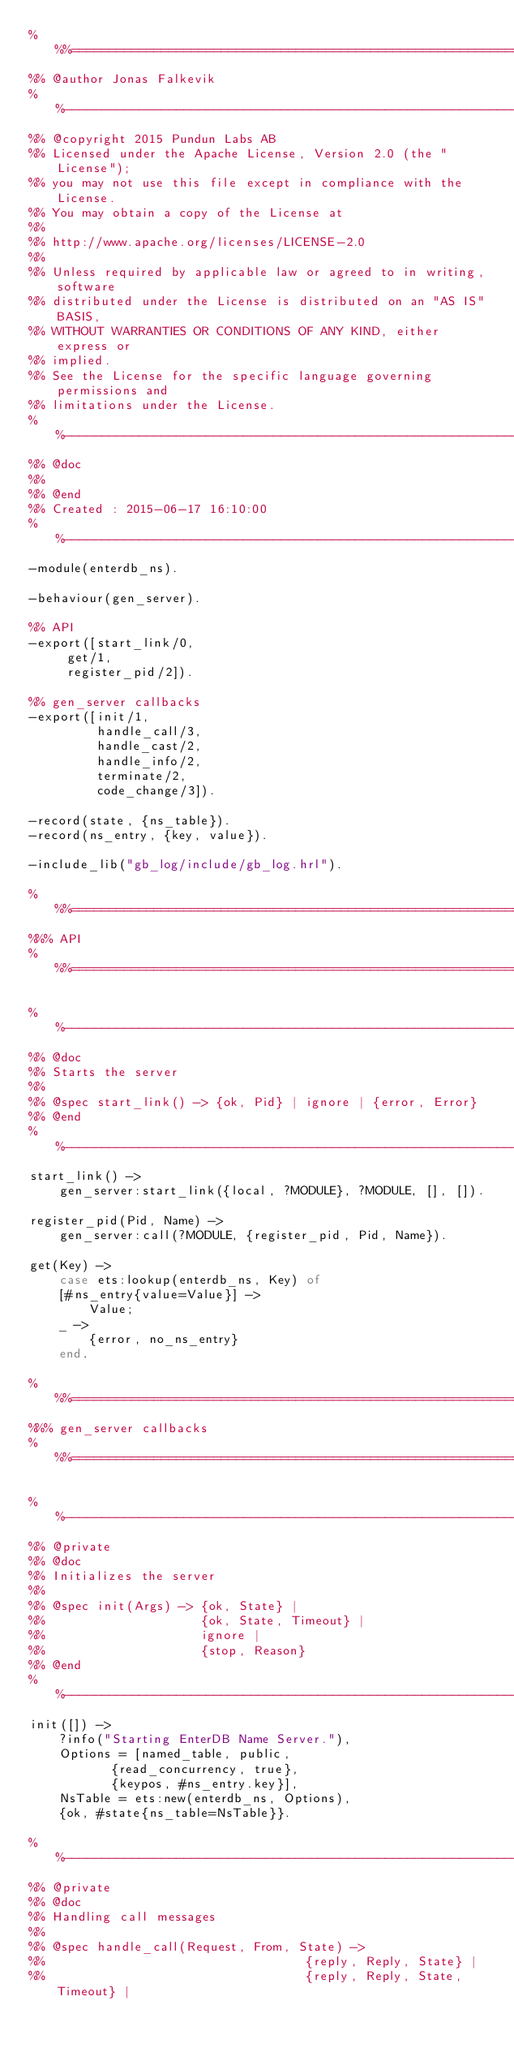<code> <loc_0><loc_0><loc_500><loc_500><_Erlang_>%%%===================================================================
%% @author Jonas Falkevik
%%--------------------------------------------------------------------
%% @copyright 2015 Pundun Labs AB
%% Licensed under the Apache License, Version 2.0 (the "License");
%% you may not use this file except in compliance with the License.
%% You may obtain a copy of the License at
%%
%% http://www.apache.org/licenses/LICENSE-2.0
%%
%% Unless required by applicable law or agreed to in writing, software
%% distributed under the License is distributed on an "AS IS" BASIS,
%% WITHOUT WARRANTIES OR CONDITIONS OF ANY KIND, either express or
%% implied.
%% See the License for the specific language governing permissions and
%% limitations under the License.
%%-------------------------------------------------------------------
%% @doc
%%
%% @end
%% Created : 2015-06-17 16:10:00
%%-------------------------------------------------------------------
-module(enterdb_ns).

-behaviour(gen_server).

%% API
-export([start_link/0,
	 get/1,
	 register_pid/2]).

%% gen_server callbacks
-export([init/1,
         handle_call/3,
         handle_cast/2,
         handle_info/2,
         terminate/2,
         code_change/3]).

-record(state, {ns_table}).
-record(ns_entry, {key, value}).

-include_lib("gb_log/include/gb_log.hrl").

%%%===================================================================
%%% API
%%%===================================================================

%%--------------------------------------------------------------------
%% @doc
%% Starts the server
%%
%% @spec start_link() -> {ok, Pid} | ignore | {error, Error}
%% @end
%%--------------------------------------------------------------------
start_link() ->
    gen_server:start_link({local, ?MODULE}, ?MODULE, [], []).

register_pid(Pid, Name) ->
    gen_server:call(?MODULE, {register_pid, Pid, Name}).

get(Key) ->
    case ets:lookup(enterdb_ns, Key) of
	[#ns_entry{value=Value}] ->
	    Value;
	_ ->
	    {error, no_ns_entry}
    end.

%%%===================================================================
%%% gen_server callbacks
%%%===================================================================

%%--------------------------------------------------------------------
%% @private
%% @doc
%% Initializes the server
%%
%% @spec init(Args) -> {ok, State} |
%%                     {ok, State, Timeout} |
%%                     ignore |
%%                     {stop, Reason}
%% @end
%%--------------------------------------------------------------------
init([]) ->
    ?info("Starting EnterDB Name Server."),
    Options = [named_table, public,
	       {read_concurrency, true},
	       {keypos, #ns_entry.key}],
    NsTable = ets:new(enterdb_ns, Options),
    {ok, #state{ns_table=NsTable}}.

%%--------------------------------------------------------------------
%% @private
%% @doc
%% Handling call messages
%%
%% @spec handle_call(Request, From, State) ->
%%                                   {reply, Reply, State} |
%%                                   {reply, Reply, State, Timeout} |</code> 